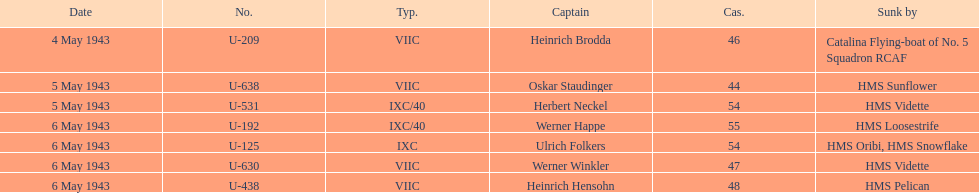Which u-boat had more than 54 casualties? U-192. 